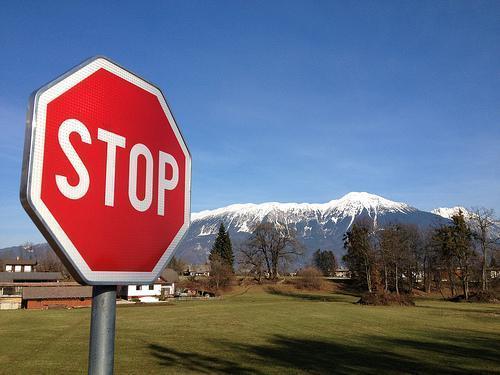How many road signs are there?
Give a very brief answer. 1. 